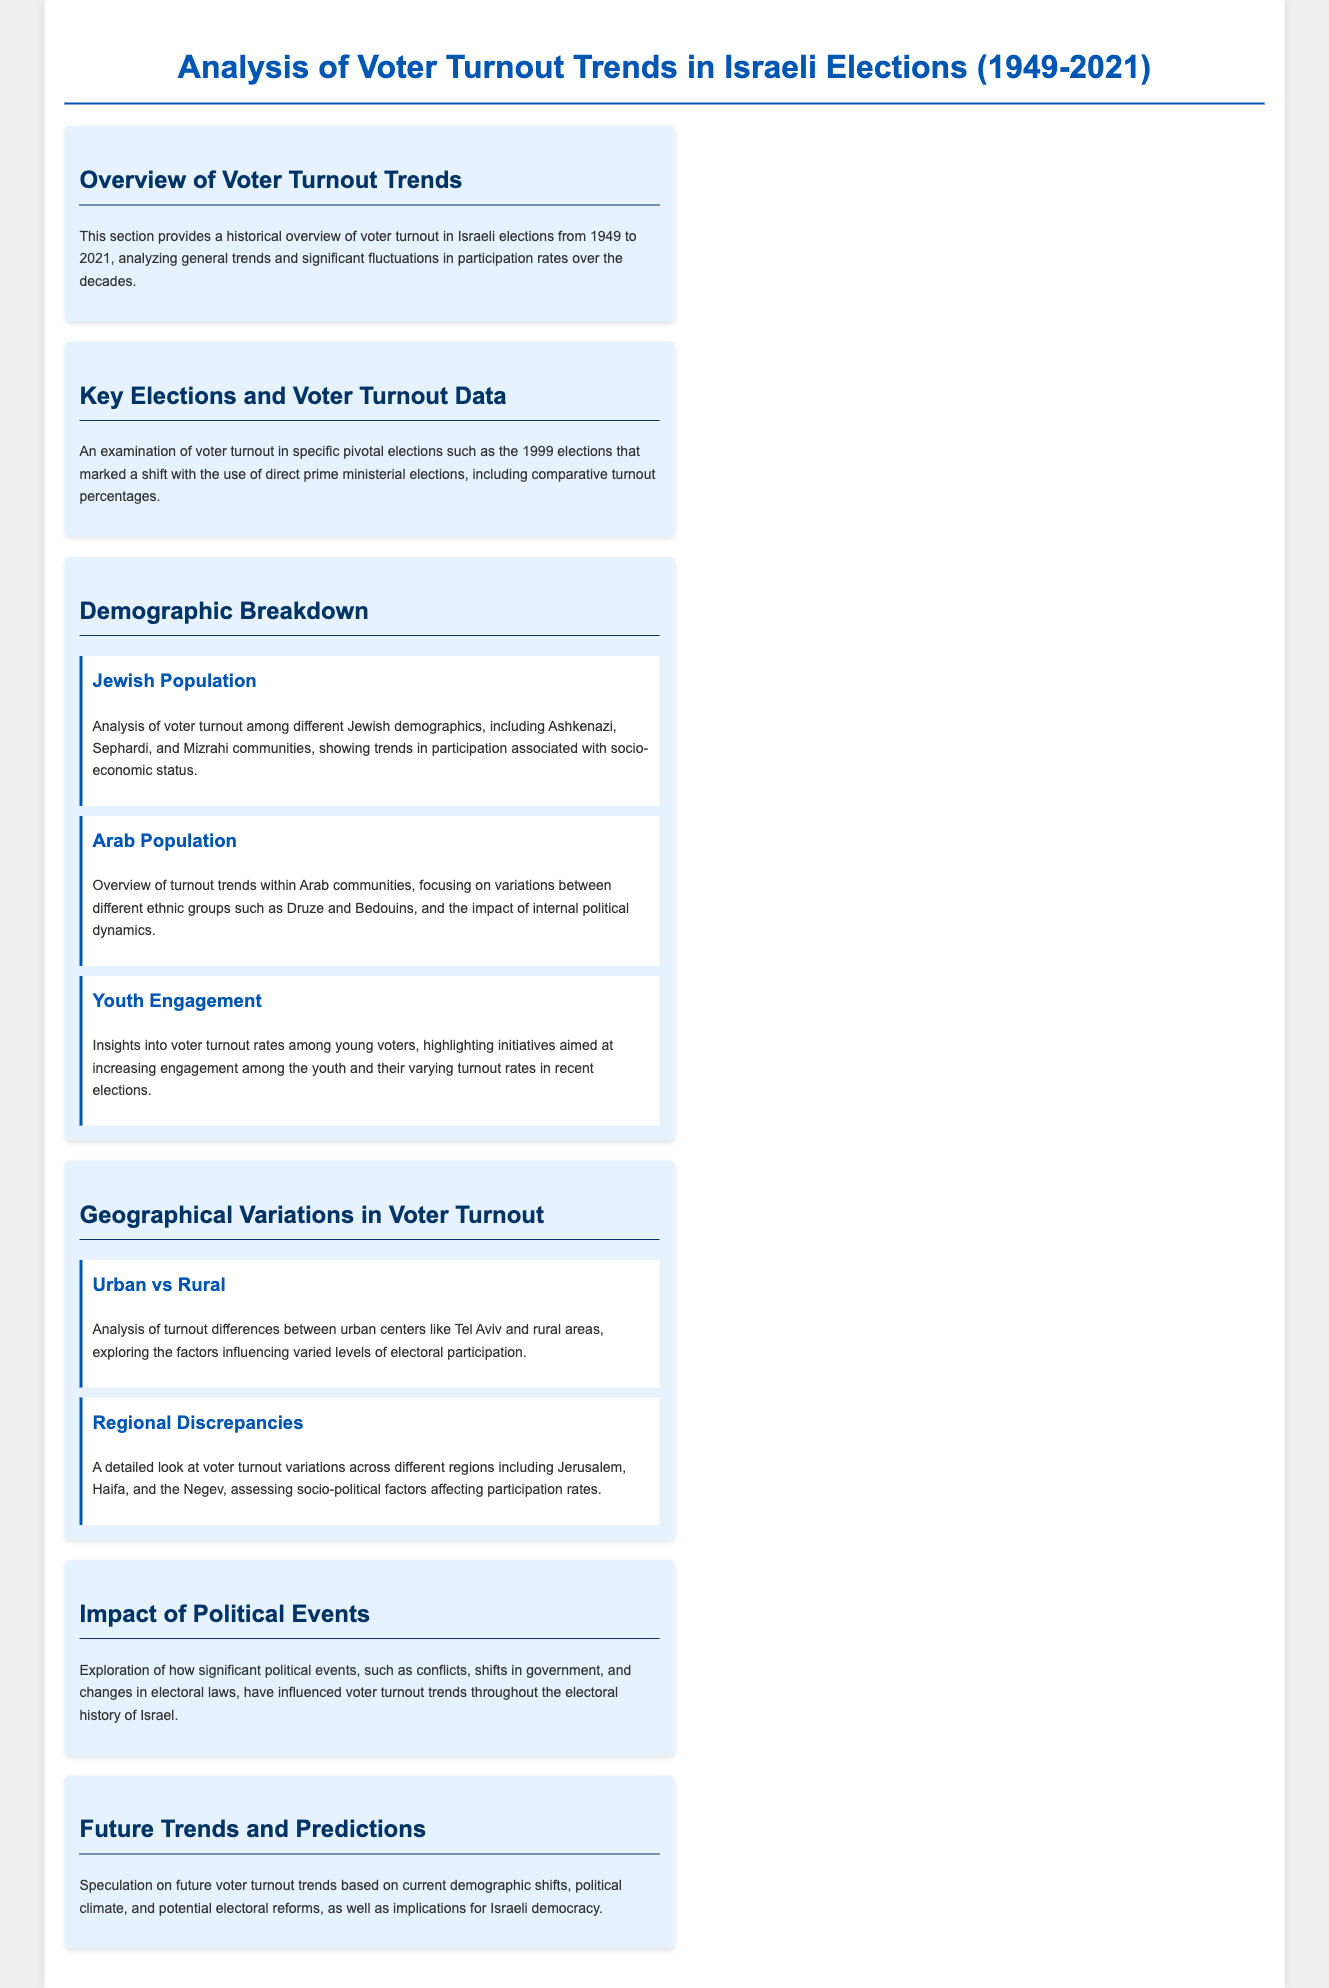What is the time span of the voter turnout analysis? The document covers Israeli elections from 1949 to 2021.
Answer: 1949 to 2021 What significant election is highlighted for its voter turnout? The document mentions the pivotal 1999 elections as a key election due to the shift in prime ministerial elections.
Answer: 1999 Which Jewish demographics are analyzed in the voter turnout section? The demographic breakdown includes Ashkenazi, Sephardi, and Mizrahi communities.
Answer: Ashkenazi, Sephardi, and Mizrahi What demographic group shows variations in participation rates due to internal dynamics? The document specifies Arab communities experiencing varying turnout trends based on political dynamics.
Answer: Arab communities Which geographical areas are compared regarding voter turnout differences? The analysis compares urban centers like Tel Aviv and rural areas for their turnout differences.
Answer: Urban centers and rural areas What event types are explored in relation to their impact on voter turnout? The document explores significant political events such as conflicts and changes in electoral laws.
Answer: Conflicts and changes in electoral laws What prediction is made regarding future voter turnout trends? The document speculates on future turnout trends based on current demographic shifts and political climate.
Answer: Current demographic shifts and political climate Which section provides insights into youth voter engagement? The subsection on Youth Engagement discusses turnout rates among young voters and initiatives to increase engagement.
Answer: Youth Engagement 